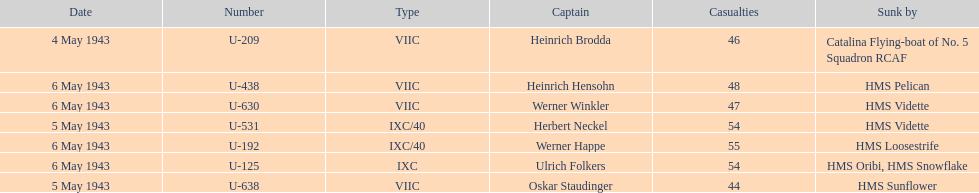What was the number of casualties on may 4 1943? 46. 